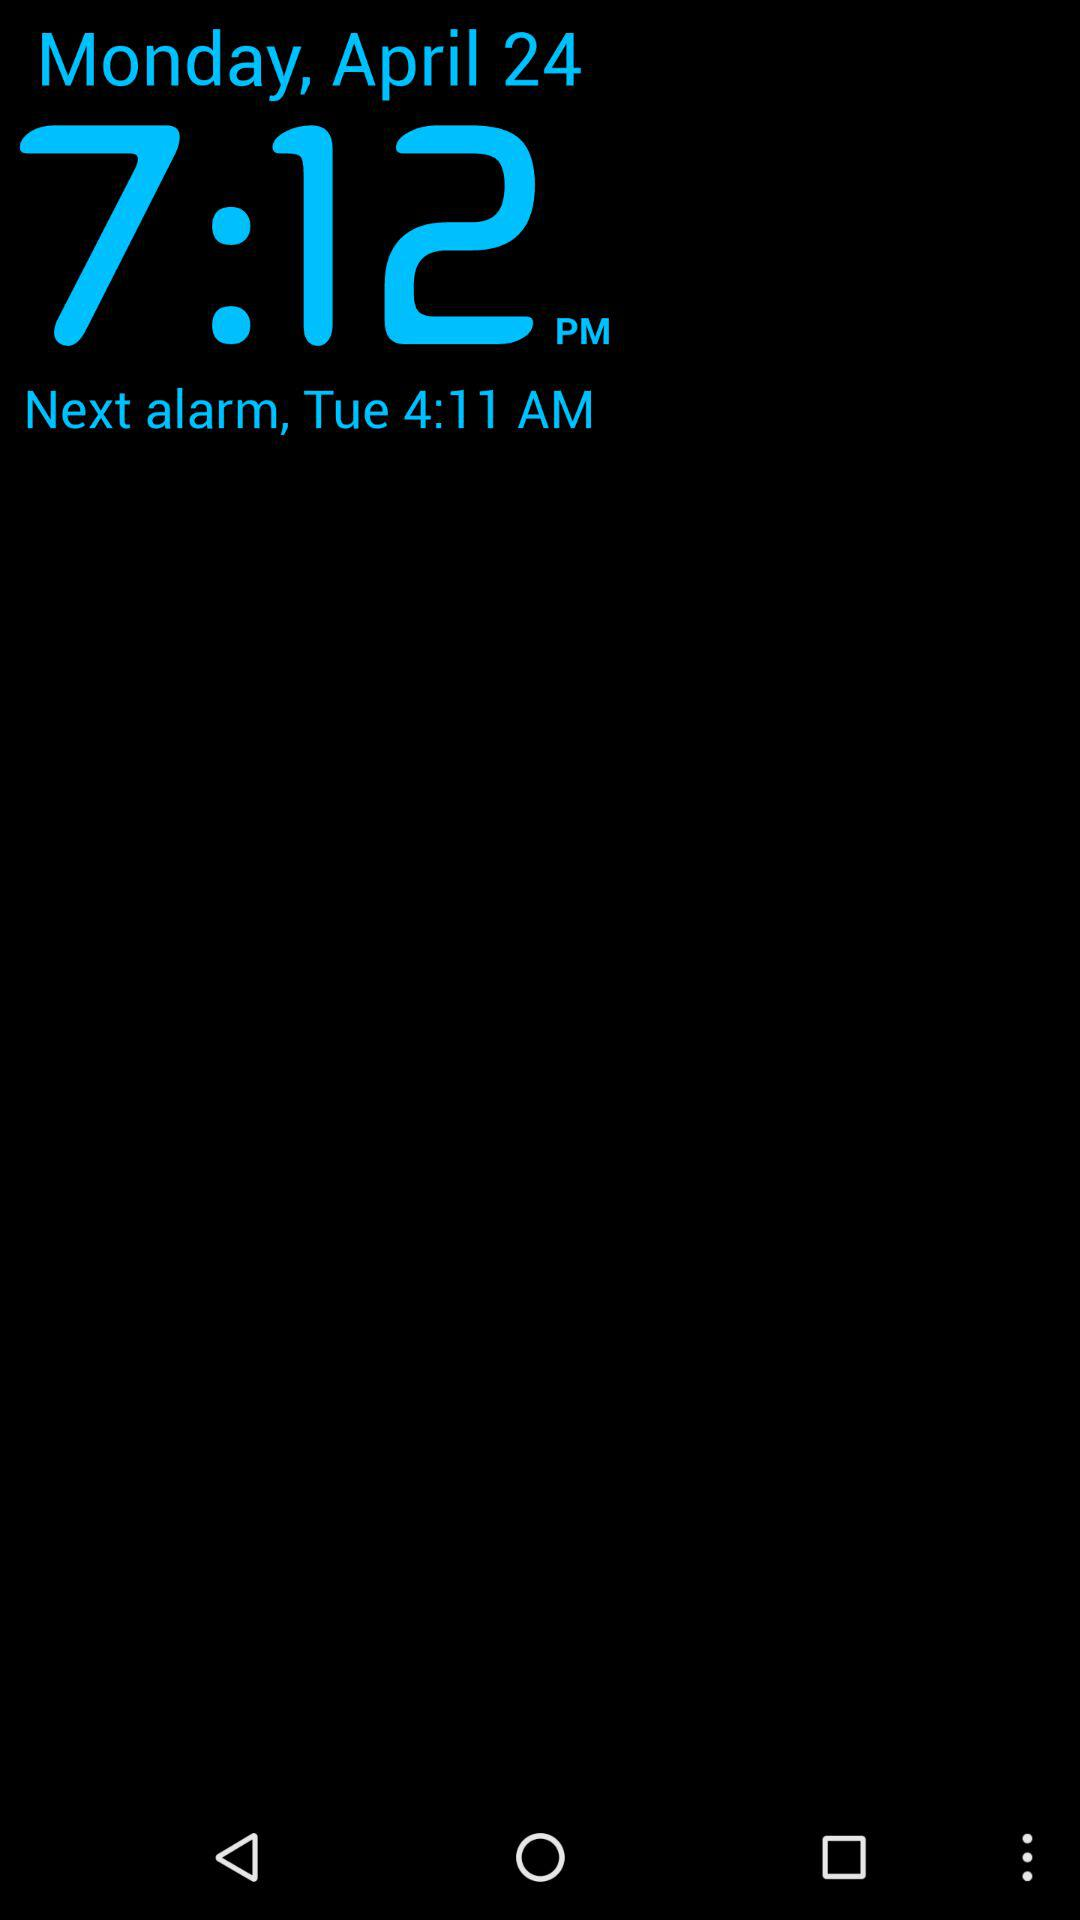What is the day of the next alarm? The day is Tuesday. 